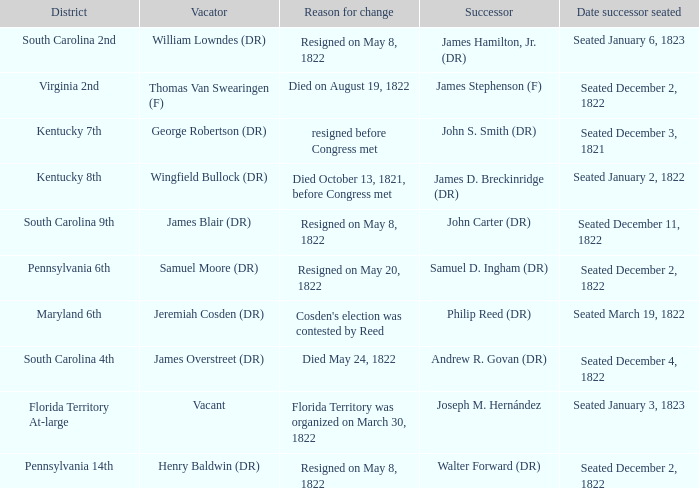Who is the successor when florida territory at-large is the district? Joseph M. Hernández. 